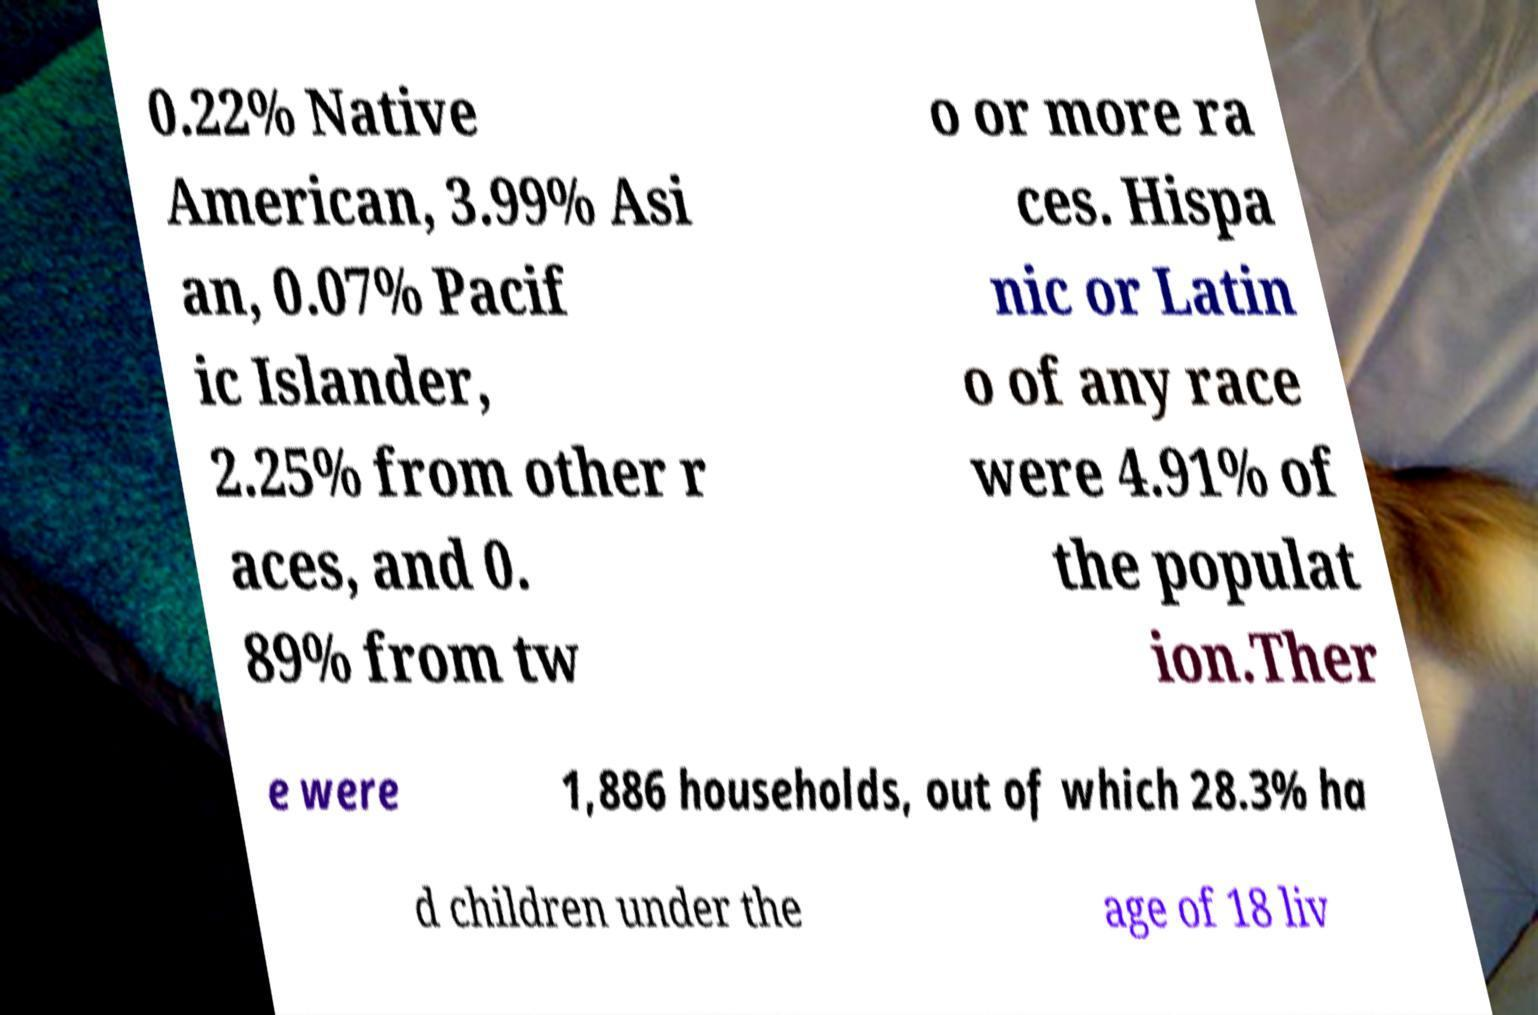There's text embedded in this image that I need extracted. Can you transcribe it verbatim? 0.22% Native American, 3.99% Asi an, 0.07% Pacif ic Islander, 2.25% from other r aces, and 0. 89% from tw o or more ra ces. Hispa nic or Latin o of any race were 4.91% of the populat ion.Ther e were 1,886 households, out of which 28.3% ha d children under the age of 18 liv 